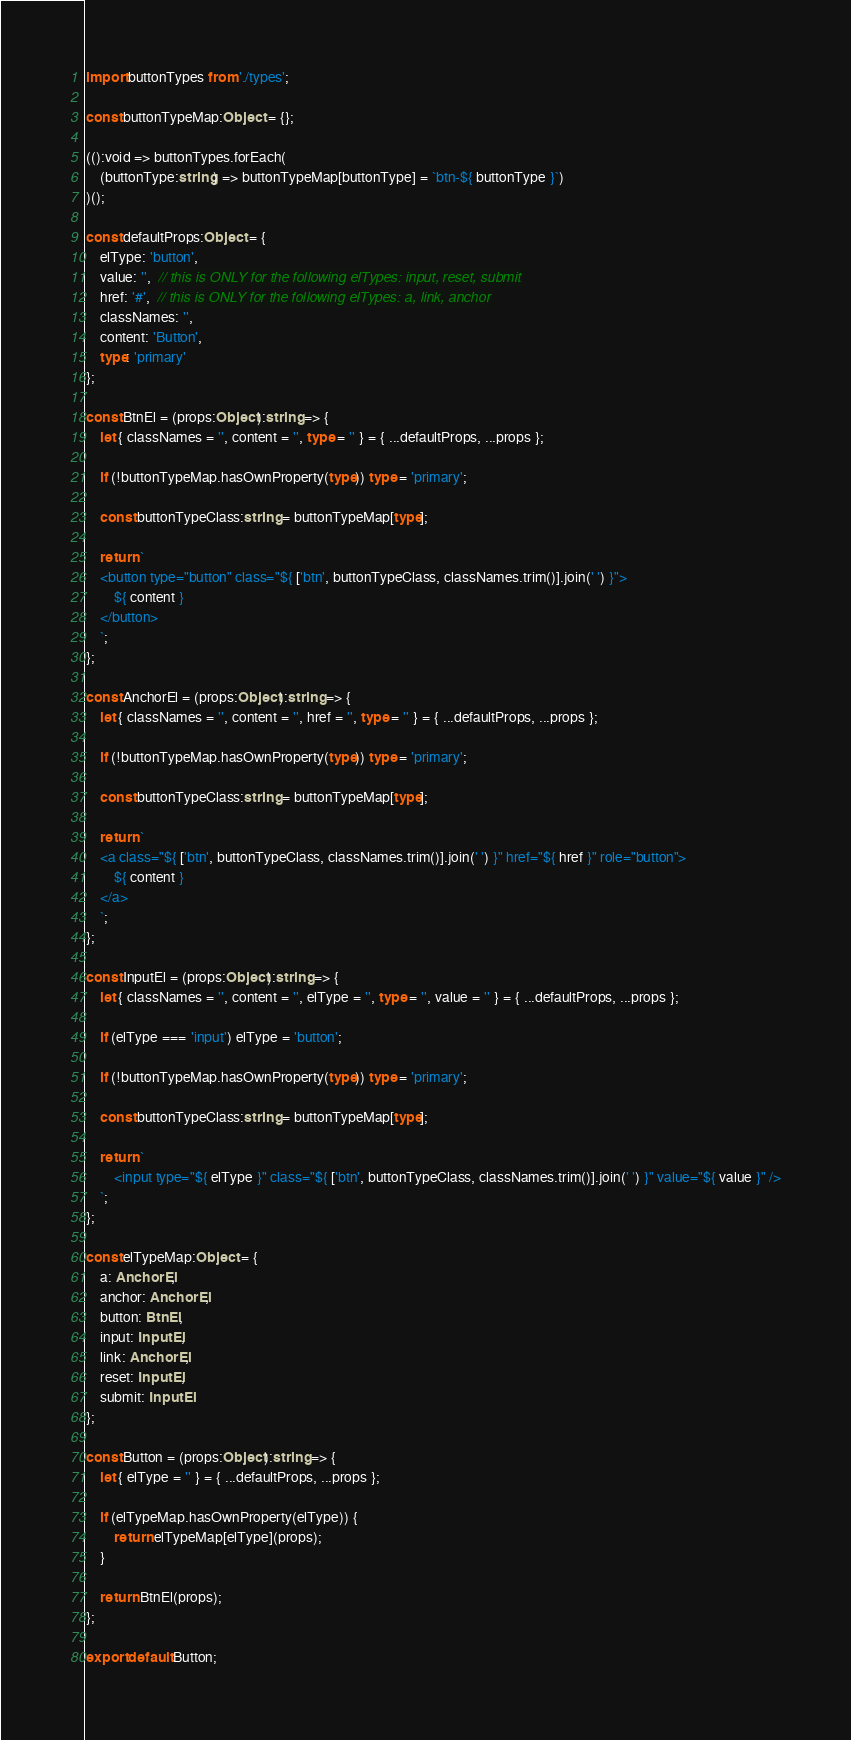<code> <loc_0><loc_0><loc_500><loc_500><_TypeScript_>import buttonTypes from './types';

const buttonTypeMap:Object = {};

(():void => buttonTypes.forEach(
	(buttonType:string) => buttonTypeMap[buttonType] = `btn-${ buttonType }`)
)();

const defaultProps:Object = {
	elType: 'button',
	value: '',  // this is ONLY for the following elTypes: input, reset, submit
	href: '#',  // this is ONLY for the following elTypes: a, link, anchor
	classNames: '',
	content: 'Button',
	type: 'primary'
};

const BtnEl = (props:Object):string => {
	let { classNames = '', content = '', type = '' } = { ...defaultProps, ...props };

	if (!buttonTypeMap.hasOwnProperty(type)) type = 'primary';

	const buttonTypeClass:string = buttonTypeMap[type];

	return `
	<button type="button" class="${ ['btn', buttonTypeClass, classNames.trim()].join(' ') }">
		${ content }
	</button>
	`;
};

const AnchorEl = (props:Object):string => {
	let { classNames = '', content = '', href = '', type = '' } = { ...defaultProps, ...props };

	if (!buttonTypeMap.hasOwnProperty(type)) type = 'primary';

	const buttonTypeClass:string = buttonTypeMap[type];

	return `
	<a class="${ ['btn', buttonTypeClass, classNames.trim()].join(' ') }" href="${ href }" role="button">
		${ content }
	</a>
	`;
};

const InputEl = (props:Object):string => {
	let { classNames = '', content = '', elType = '', type = '', value = '' } = { ...defaultProps, ...props };

	if (elType === 'input') elType = 'button';

	if (!buttonTypeMap.hasOwnProperty(type)) type = 'primary';

	const buttonTypeClass:string = buttonTypeMap[type];

	return `
		<input type="${ elType }" class="${ ['btn', buttonTypeClass, classNames.trim()].join(' ') }" value="${ value }" />
	`;
};

const elTypeMap:Object = {
	a: AnchorEl,
	anchor: AnchorEl,
	button: BtnEl,
	input: InputEl,
	link: AnchorEl,
	reset: InputEl,
	submit: InputEl
};

const Button = (props:Object):string => {
	let { elType = '' } = { ...defaultProps, ...props };

	if (elTypeMap.hasOwnProperty(elType)) {
		return elTypeMap[elType](props);
	}

	return BtnEl(props);
};

export default Button;
</code> 